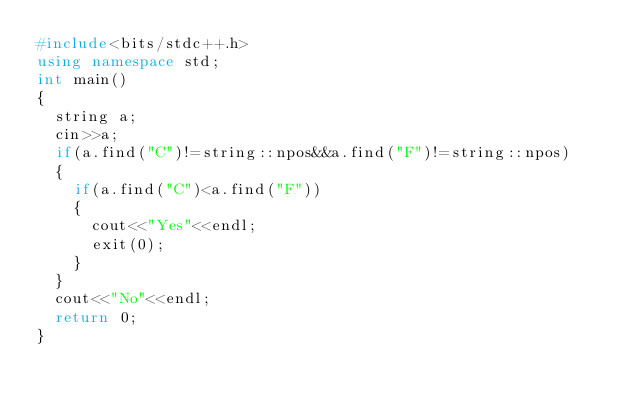<code> <loc_0><loc_0><loc_500><loc_500><_C++_>#include<bits/stdc++.h>
using namespace std;
int main()
{
	string a;
	cin>>a;
	if(a.find("C")!=string::npos&&a.find("F")!=string::npos)
	{
		if(a.find("C")<a.find("F"))
		{
			cout<<"Yes"<<endl;
			exit(0);
		}
	}
	cout<<"No"<<endl;
	return 0;
}</code> 